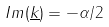<formula> <loc_0><loc_0><loc_500><loc_500>I m ( \underline { k } ) = - \alpha / 2</formula> 